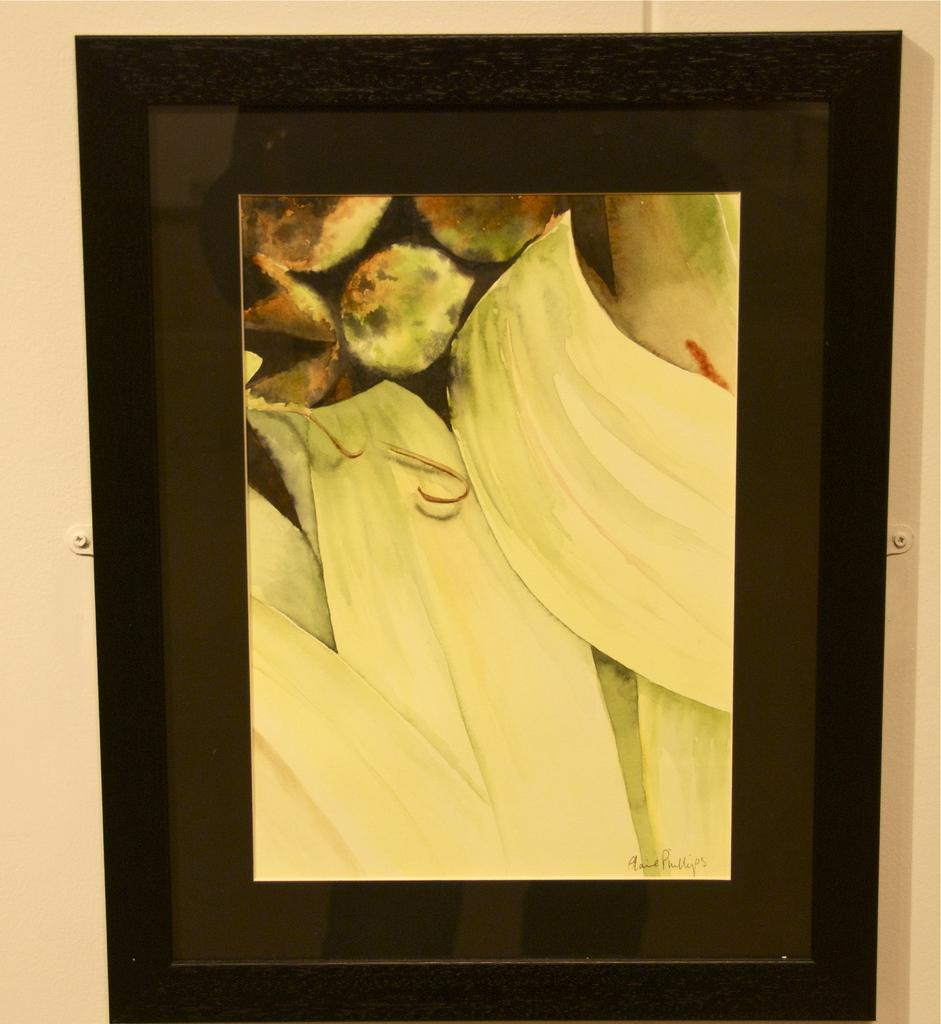What is the main object in the image? There is a frame in the image. What is inside the frame? The frame contains a painting. What is the subject of the painting? The painting depicts leaves. What type of songs can be heard coming from the leaves in the painting? There are no songs present in the image, as it features a painting of leaves. 